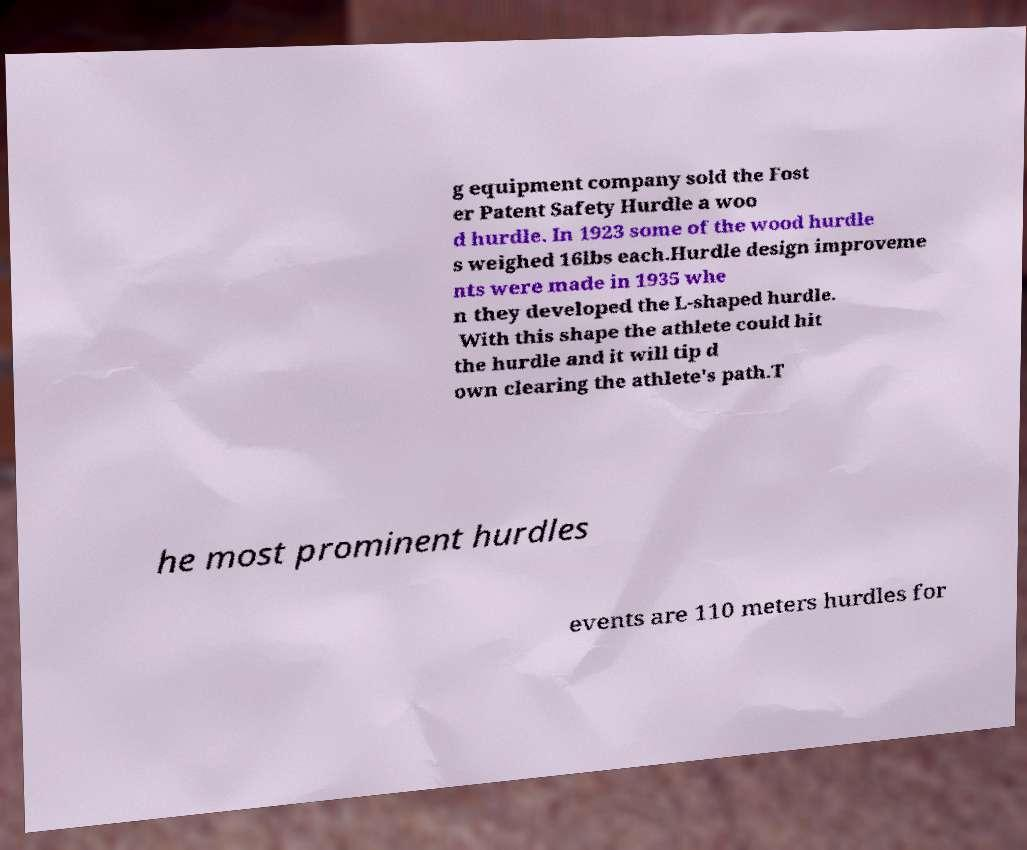Can you accurately transcribe the text from the provided image for me? g equipment company sold the Fost er Patent Safety Hurdle a woo d hurdle. In 1923 some of the wood hurdle s weighed 16lbs each.Hurdle design improveme nts were made in 1935 whe n they developed the L-shaped hurdle. With this shape the athlete could hit the hurdle and it will tip d own clearing the athlete's path.T he most prominent hurdles events are 110 meters hurdles for 